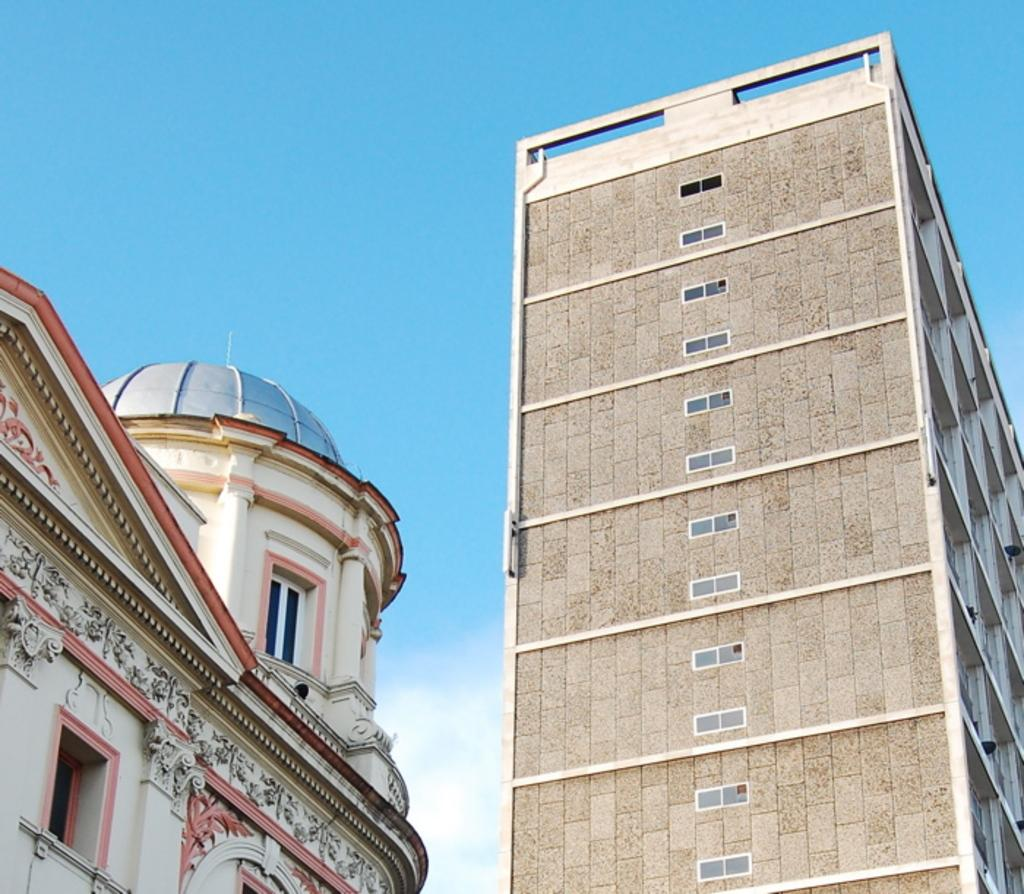What type of view is shown in the image? The image is an outside view. How many buildings can be seen at the bottom of the image? There are two buildings at the bottom of the image. What is visible at the top of the image? The sky is visible at the top of the image. What is the color of the sky in the image? The color of the sky is blue. Can you see a tin kettle hanging from one of the buildings in the image? There is no tin kettle visible in the image. 